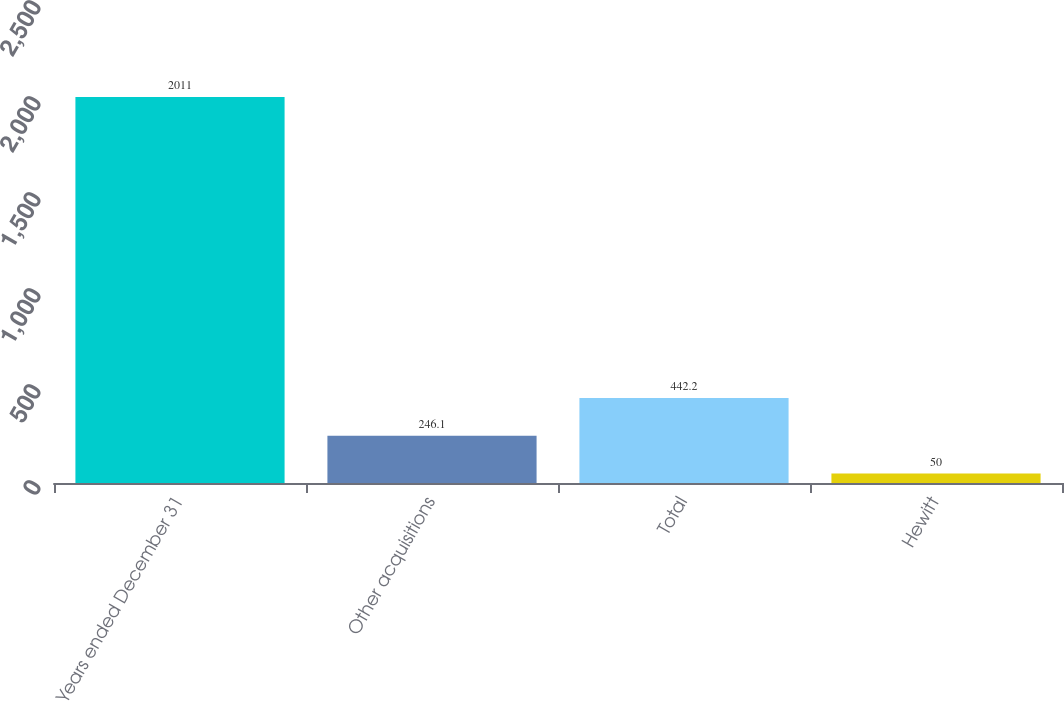Convert chart to OTSL. <chart><loc_0><loc_0><loc_500><loc_500><bar_chart><fcel>Years ended December 31<fcel>Other acquisitions<fcel>Total<fcel>Hewitt<nl><fcel>2011<fcel>246.1<fcel>442.2<fcel>50<nl></chart> 